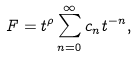Convert formula to latex. <formula><loc_0><loc_0><loc_500><loc_500>F = t ^ { \rho } \sum _ { n = 0 } ^ { \infty } c _ { n } t ^ { - n } ,</formula> 